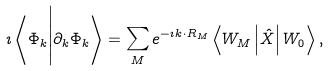Convert formula to latex. <formula><loc_0><loc_0><loc_500><loc_500>\imath \left < \Phi _ { k } \Big | \partial _ { k } \Phi _ { k } \right > = \sum _ { M } e ^ { - \imath { k } \cdot { R } _ { M } } \left < W _ { M } \left | \hat { X } \right | W _ { 0 } \right > ,</formula> 